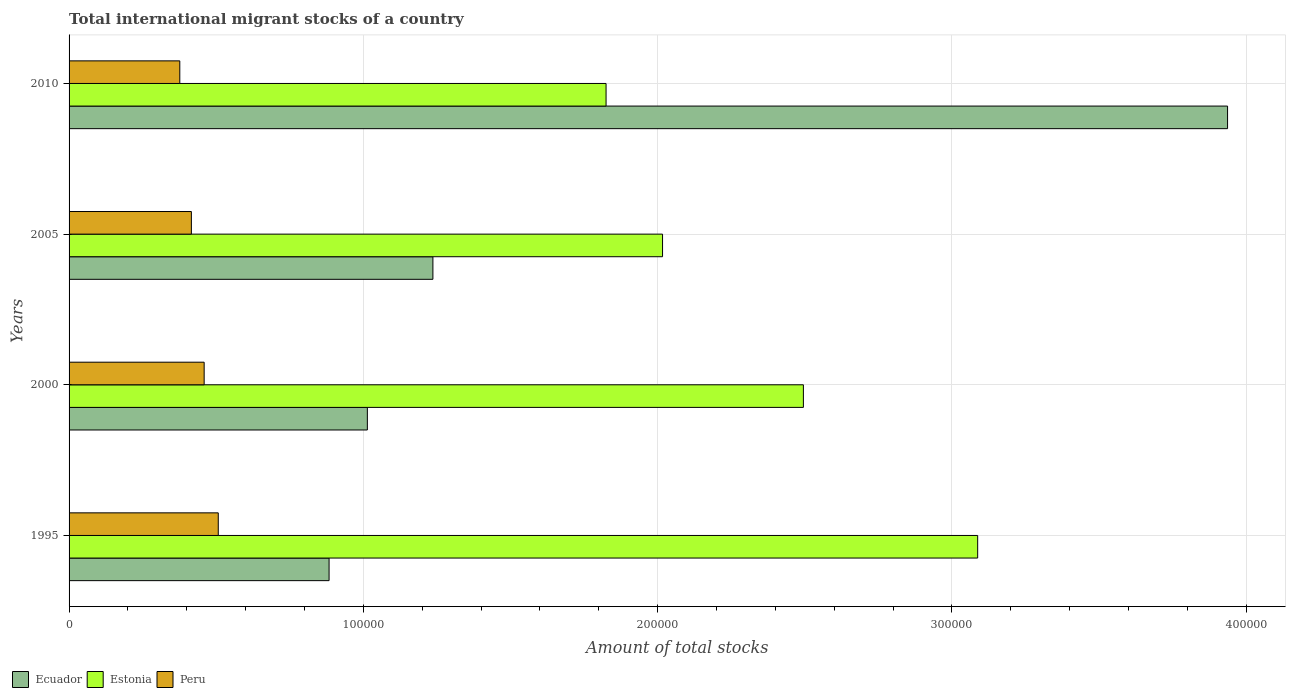How many groups of bars are there?
Offer a very short reply. 4. Are the number of bars on each tick of the Y-axis equal?
Provide a succinct answer. Yes. How many bars are there on the 1st tick from the top?
Provide a succinct answer. 3. What is the label of the 1st group of bars from the top?
Provide a succinct answer. 2010. In how many cases, is the number of bars for a given year not equal to the number of legend labels?
Your answer should be compact. 0. What is the amount of total stocks in in Peru in 2005?
Ensure brevity in your answer.  4.16e+04. Across all years, what is the maximum amount of total stocks in in Peru?
Offer a very short reply. 5.07e+04. Across all years, what is the minimum amount of total stocks in in Peru?
Your answer should be very brief. 3.76e+04. In which year was the amount of total stocks in in Estonia maximum?
Your answer should be very brief. 1995. In which year was the amount of total stocks in in Peru minimum?
Give a very brief answer. 2010. What is the total amount of total stocks in in Peru in the graph?
Provide a succinct answer. 1.76e+05. What is the difference between the amount of total stocks in in Estonia in 1995 and that in 2000?
Offer a very short reply. 5.92e+04. What is the difference between the amount of total stocks in in Peru in 2005 and the amount of total stocks in in Ecuador in 2000?
Keep it short and to the point. -5.98e+04. What is the average amount of total stocks in in Peru per year?
Provide a succinct answer. 4.39e+04. In the year 2010, what is the difference between the amount of total stocks in in Peru and amount of total stocks in in Estonia?
Your answer should be very brief. -1.45e+05. In how many years, is the amount of total stocks in in Ecuador greater than 280000 ?
Make the answer very short. 1. What is the ratio of the amount of total stocks in in Estonia in 1995 to that in 2010?
Provide a short and direct response. 1.69. Is the amount of total stocks in in Ecuador in 1995 less than that in 2005?
Keep it short and to the point. Yes. Is the difference between the amount of total stocks in in Peru in 1995 and 2005 greater than the difference between the amount of total stocks in in Estonia in 1995 and 2005?
Your response must be concise. No. What is the difference between the highest and the second highest amount of total stocks in in Peru?
Give a very brief answer. 4797. What is the difference between the highest and the lowest amount of total stocks in in Estonia?
Your answer should be very brief. 1.26e+05. What does the 1st bar from the top in 2005 represents?
Give a very brief answer. Peru. What does the 2nd bar from the bottom in 2005 represents?
Give a very brief answer. Estonia. Is it the case that in every year, the sum of the amount of total stocks in in Peru and amount of total stocks in in Ecuador is greater than the amount of total stocks in in Estonia?
Offer a terse response. No. Are all the bars in the graph horizontal?
Ensure brevity in your answer.  Yes. How many years are there in the graph?
Offer a very short reply. 4. Does the graph contain grids?
Ensure brevity in your answer.  Yes. Where does the legend appear in the graph?
Make the answer very short. Bottom left. How are the legend labels stacked?
Your answer should be compact. Horizontal. What is the title of the graph?
Your answer should be compact. Total international migrant stocks of a country. What is the label or title of the X-axis?
Your response must be concise. Amount of total stocks. What is the Amount of total stocks of Ecuador in 1995?
Keep it short and to the point. 8.83e+04. What is the Amount of total stocks in Estonia in 1995?
Your response must be concise. 3.09e+05. What is the Amount of total stocks in Peru in 1995?
Ensure brevity in your answer.  5.07e+04. What is the Amount of total stocks of Ecuador in 2000?
Provide a short and direct response. 1.01e+05. What is the Amount of total stocks in Estonia in 2000?
Your answer should be very brief. 2.50e+05. What is the Amount of total stocks of Peru in 2000?
Your response must be concise. 4.59e+04. What is the Amount of total stocks in Ecuador in 2005?
Offer a very short reply. 1.24e+05. What is the Amount of total stocks of Estonia in 2005?
Offer a terse response. 2.02e+05. What is the Amount of total stocks of Peru in 2005?
Your answer should be compact. 4.16e+04. What is the Amount of total stocks of Ecuador in 2010?
Make the answer very short. 3.94e+05. What is the Amount of total stocks in Estonia in 2010?
Your response must be concise. 1.82e+05. What is the Amount of total stocks of Peru in 2010?
Your response must be concise. 3.76e+04. Across all years, what is the maximum Amount of total stocks of Ecuador?
Ensure brevity in your answer.  3.94e+05. Across all years, what is the maximum Amount of total stocks in Estonia?
Provide a succinct answer. 3.09e+05. Across all years, what is the maximum Amount of total stocks of Peru?
Make the answer very short. 5.07e+04. Across all years, what is the minimum Amount of total stocks in Ecuador?
Offer a terse response. 8.83e+04. Across all years, what is the minimum Amount of total stocks in Estonia?
Offer a very short reply. 1.82e+05. Across all years, what is the minimum Amount of total stocks of Peru?
Offer a very short reply. 3.76e+04. What is the total Amount of total stocks in Ecuador in the graph?
Offer a very short reply. 7.07e+05. What is the total Amount of total stocks in Estonia in the graph?
Offer a terse response. 9.42e+05. What is the total Amount of total stocks in Peru in the graph?
Your answer should be compact. 1.76e+05. What is the difference between the Amount of total stocks of Ecuador in 1995 and that in 2000?
Your answer should be compact. -1.30e+04. What is the difference between the Amount of total stocks of Estonia in 1995 and that in 2000?
Your response must be concise. 5.92e+04. What is the difference between the Amount of total stocks of Peru in 1995 and that in 2000?
Keep it short and to the point. 4797. What is the difference between the Amount of total stocks of Ecuador in 1995 and that in 2005?
Keep it short and to the point. -3.53e+04. What is the difference between the Amount of total stocks of Estonia in 1995 and that in 2005?
Offer a very short reply. 1.07e+05. What is the difference between the Amount of total stocks of Peru in 1995 and that in 2005?
Keep it short and to the point. 9139. What is the difference between the Amount of total stocks in Ecuador in 1995 and that in 2010?
Give a very brief answer. -3.05e+05. What is the difference between the Amount of total stocks in Estonia in 1995 and that in 2010?
Give a very brief answer. 1.26e+05. What is the difference between the Amount of total stocks in Peru in 1995 and that in 2010?
Offer a very short reply. 1.31e+04. What is the difference between the Amount of total stocks of Ecuador in 2000 and that in 2005?
Your response must be concise. -2.23e+04. What is the difference between the Amount of total stocks of Estonia in 2000 and that in 2005?
Your response must be concise. 4.79e+04. What is the difference between the Amount of total stocks of Peru in 2000 and that in 2005?
Offer a terse response. 4342. What is the difference between the Amount of total stocks in Ecuador in 2000 and that in 2010?
Your answer should be very brief. -2.92e+05. What is the difference between the Amount of total stocks in Estonia in 2000 and that in 2010?
Give a very brief answer. 6.70e+04. What is the difference between the Amount of total stocks in Peru in 2000 and that in 2010?
Provide a short and direct response. 8274. What is the difference between the Amount of total stocks in Ecuador in 2005 and that in 2010?
Give a very brief answer. -2.70e+05. What is the difference between the Amount of total stocks of Estonia in 2005 and that in 2010?
Your answer should be very brief. 1.92e+04. What is the difference between the Amount of total stocks of Peru in 2005 and that in 2010?
Provide a succinct answer. 3932. What is the difference between the Amount of total stocks of Ecuador in 1995 and the Amount of total stocks of Estonia in 2000?
Your response must be concise. -1.61e+05. What is the difference between the Amount of total stocks in Ecuador in 1995 and the Amount of total stocks in Peru in 2000?
Keep it short and to the point. 4.24e+04. What is the difference between the Amount of total stocks in Estonia in 1995 and the Amount of total stocks in Peru in 2000?
Provide a succinct answer. 2.63e+05. What is the difference between the Amount of total stocks in Ecuador in 1995 and the Amount of total stocks in Estonia in 2005?
Your answer should be very brief. -1.13e+05. What is the difference between the Amount of total stocks in Ecuador in 1995 and the Amount of total stocks in Peru in 2005?
Provide a succinct answer. 4.68e+04. What is the difference between the Amount of total stocks of Estonia in 1995 and the Amount of total stocks of Peru in 2005?
Your answer should be compact. 2.67e+05. What is the difference between the Amount of total stocks in Ecuador in 1995 and the Amount of total stocks in Estonia in 2010?
Offer a very short reply. -9.41e+04. What is the difference between the Amount of total stocks of Ecuador in 1995 and the Amount of total stocks of Peru in 2010?
Give a very brief answer. 5.07e+04. What is the difference between the Amount of total stocks of Estonia in 1995 and the Amount of total stocks of Peru in 2010?
Your response must be concise. 2.71e+05. What is the difference between the Amount of total stocks of Ecuador in 2000 and the Amount of total stocks of Estonia in 2005?
Your answer should be compact. -1.00e+05. What is the difference between the Amount of total stocks in Ecuador in 2000 and the Amount of total stocks in Peru in 2005?
Offer a terse response. 5.98e+04. What is the difference between the Amount of total stocks of Estonia in 2000 and the Amount of total stocks of Peru in 2005?
Your answer should be compact. 2.08e+05. What is the difference between the Amount of total stocks in Ecuador in 2000 and the Amount of total stocks in Estonia in 2010?
Give a very brief answer. -8.11e+04. What is the difference between the Amount of total stocks of Ecuador in 2000 and the Amount of total stocks of Peru in 2010?
Offer a very short reply. 6.37e+04. What is the difference between the Amount of total stocks in Estonia in 2000 and the Amount of total stocks in Peru in 2010?
Ensure brevity in your answer.  2.12e+05. What is the difference between the Amount of total stocks in Ecuador in 2005 and the Amount of total stocks in Estonia in 2010?
Give a very brief answer. -5.88e+04. What is the difference between the Amount of total stocks in Ecuador in 2005 and the Amount of total stocks in Peru in 2010?
Your answer should be compact. 8.60e+04. What is the difference between the Amount of total stocks in Estonia in 2005 and the Amount of total stocks in Peru in 2010?
Provide a short and direct response. 1.64e+05. What is the average Amount of total stocks of Ecuador per year?
Ensure brevity in your answer.  1.77e+05. What is the average Amount of total stocks of Estonia per year?
Ensure brevity in your answer.  2.36e+05. What is the average Amount of total stocks of Peru per year?
Your answer should be very brief. 4.39e+04. In the year 1995, what is the difference between the Amount of total stocks in Ecuador and Amount of total stocks in Estonia?
Offer a terse response. -2.20e+05. In the year 1995, what is the difference between the Amount of total stocks of Ecuador and Amount of total stocks of Peru?
Your answer should be very brief. 3.77e+04. In the year 1995, what is the difference between the Amount of total stocks of Estonia and Amount of total stocks of Peru?
Your answer should be very brief. 2.58e+05. In the year 2000, what is the difference between the Amount of total stocks in Ecuador and Amount of total stocks in Estonia?
Provide a short and direct response. -1.48e+05. In the year 2000, what is the difference between the Amount of total stocks of Ecuador and Amount of total stocks of Peru?
Your response must be concise. 5.55e+04. In the year 2000, what is the difference between the Amount of total stocks in Estonia and Amount of total stocks in Peru?
Provide a short and direct response. 2.04e+05. In the year 2005, what is the difference between the Amount of total stocks of Ecuador and Amount of total stocks of Estonia?
Ensure brevity in your answer.  -7.80e+04. In the year 2005, what is the difference between the Amount of total stocks in Ecuador and Amount of total stocks in Peru?
Offer a very short reply. 8.21e+04. In the year 2005, what is the difference between the Amount of total stocks of Estonia and Amount of total stocks of Peru?
Give a very brief answer. 1.60e+05. In the year 2010, what is the difference between the Amount of total stocks in Ecuador and Amount of total stocks in Estonia?
Make the answer very short. 2.11e+05. In the year 2010, what is the difference between the Amount of total stocks in Ecuador and Amount of total stocks in Peru?
Give a very brief answer. 3.56e+05. In the year 2010, what is the difference between the Amount of total stocks in Estonia and Amount of total stocks in Peru?
Provide a succinct answer. 1.45e+05. What is the ratio of the Amount of total stocks in Ecuador in 1995 to that in 2000?
Provide a succinct answer. 0.87. What is the ratio of the Amount of total stocks in Estonia in 1995 to that in 2000?
Your response must be concise. 1.24. What is the ratio of the Amount of total stocks in Peru in 1995 to that in 2000?
Give a very brief answer. 1.1. What is the ratio of the Amount of total stocks in Ecuador in 1995 to that in 2005?
Provide a short and direct response. 0.71. What is the ratio of the Amount of total stocks of Estonia in 1995 to that in 2005?
Provide a short and direct response. 1.53. What is the ratio of the Amount of total stocks in Peru in 1995 to that in 2005?
Offer a very short reply. 1.22. What is the ratio of the Amount of total stocks of Ecuador in 1995 to that in 2010?
Keep it short and to the point. 0.22. What is the ratio of the Amount of total stocks in Estonia in 1995 to that in 2010?
Keep it short and to the point. 1.69. What is the ratio of the Amount of total stocks of Peru in 1995 to that in 2010?
Keep it short and to the point. 1.35. What is the ratio of the Amount of total stocks in Ecuador in 2000 to that in 2005?
Make the answer very short. 0.82. What is the ratio of the Amount of total stocks in Estonia in 2000 to that in 2005?
Keep it short and to the point. 1.24. What is the ratio of the Amount of total stocks in Peru in 2000 to that in 2005?
Provide a succinct answer. 1.1. What is the ratio of the Amount of total stocks in Ecuador in 2000 to that in 2010?
Keep it short and to the point. 0.26. What is the ratio of the Amount of total stocks of Estonia in 2000 to that in 2010?
Your response must be concise. 1.37. What is the ratio of the Amount of total stocks of Peru in 2000 to that in 2010?
Make the answer very short. 1.22. What is the ratio of the Amount of total stocks of Ecuador in 2005 to that in 2010?
Ensure brevity in your answer.  0.31. What is the ratio of the Amount of total stocks of Estonia in 2005 to that in 2010?
Offer a very short reply. 1.11. What is the ratio of the Amount of total stocks of Peru in 2005 to that in 2010?
Your answer should be very brief. 1.1. What is the difference between the highest and the second highest Amount of total stocks in Ecuador?
Ensure brevity in your answer.  2.70e+05. What is the difference between the highest and the second highest Amount of total stocks in Estonia?
Give a very brief answer. 5.92e+04. What is the difference between the highest and the second highest Amount of total stocks of Peru?
Make the answer very short. 4797. What is the difference between the highest and the lowest Amount of total stocks in Ecuador?
Provide a succinct answer. 3.05e+05. What is the difference between the highest and the lowest Amount of total stocks in Estonia?
Offer a very short reply. 1.26e+05. What is the difference between the highest and the lowest Amount of total stocks of Peru?
Offer a terse response. 1.31e+04. 